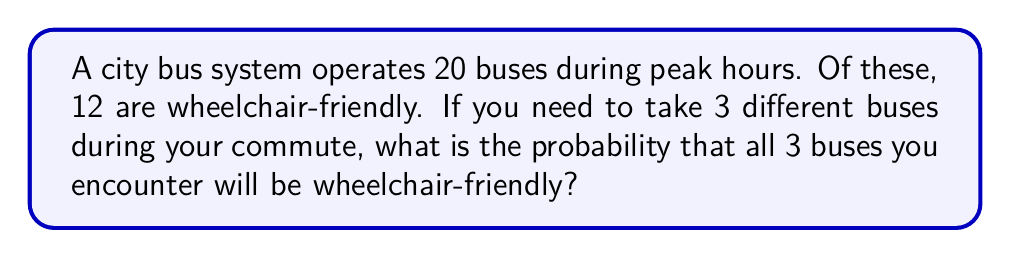Solve this math problem. Let's approach this step-by-step:

1) First, we need to understand that this is a problem of sampling without replacement. Each time we choose a bus, we're choosing from the total pool of buses.

2) The probability of the first bus being wheelchair-friendly is:

   $P(\text{1st bus wheelchair-friendly}) = \frac{12}{20} = \frac{3}{5}$

3) After we've taken the first bus, there are now 19 buses left, of which 11 are wheelchair-friendly. So the probability of the second bus being wheelchair-friendly is:

   $P(\text{2nd bus wheelchair-friendly}) = \frac{11}{19}$

4) For the third bus, there are 18 buses left, of which 10 are wheelchair-friendly:

   $P(\text{3rd bus wheelchair-friendly}) = \frac{10}{18} = \frac{5}{9}$

5) The probability of all three events occurring is the product of their individual probabilities:

   $$P(\text{all 3 wheelchair-friendly}) = \frac{3}{5} \cdot \frac{11}{19} \cdot \frac{5}{9}$$

6) Multiplying these fractions:

   $$P(\text{all 3 wheelchair-friendly}) = \frac{3 \cdot 11 \cdot 5}{5 \cdot 19 \cdot 9} = \frac{165}{855} = \frac{33}{171} \approx 0.1930$$

Therefore, the probability is $\frac{33}{171}$, or about 19.30%.
Answer: $\frac{33}{171}$ 